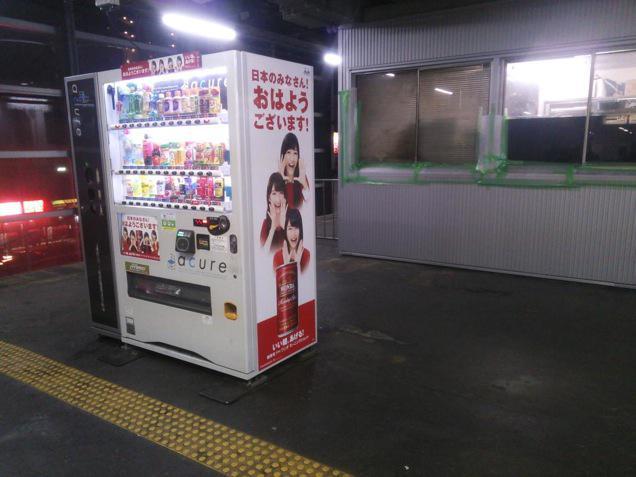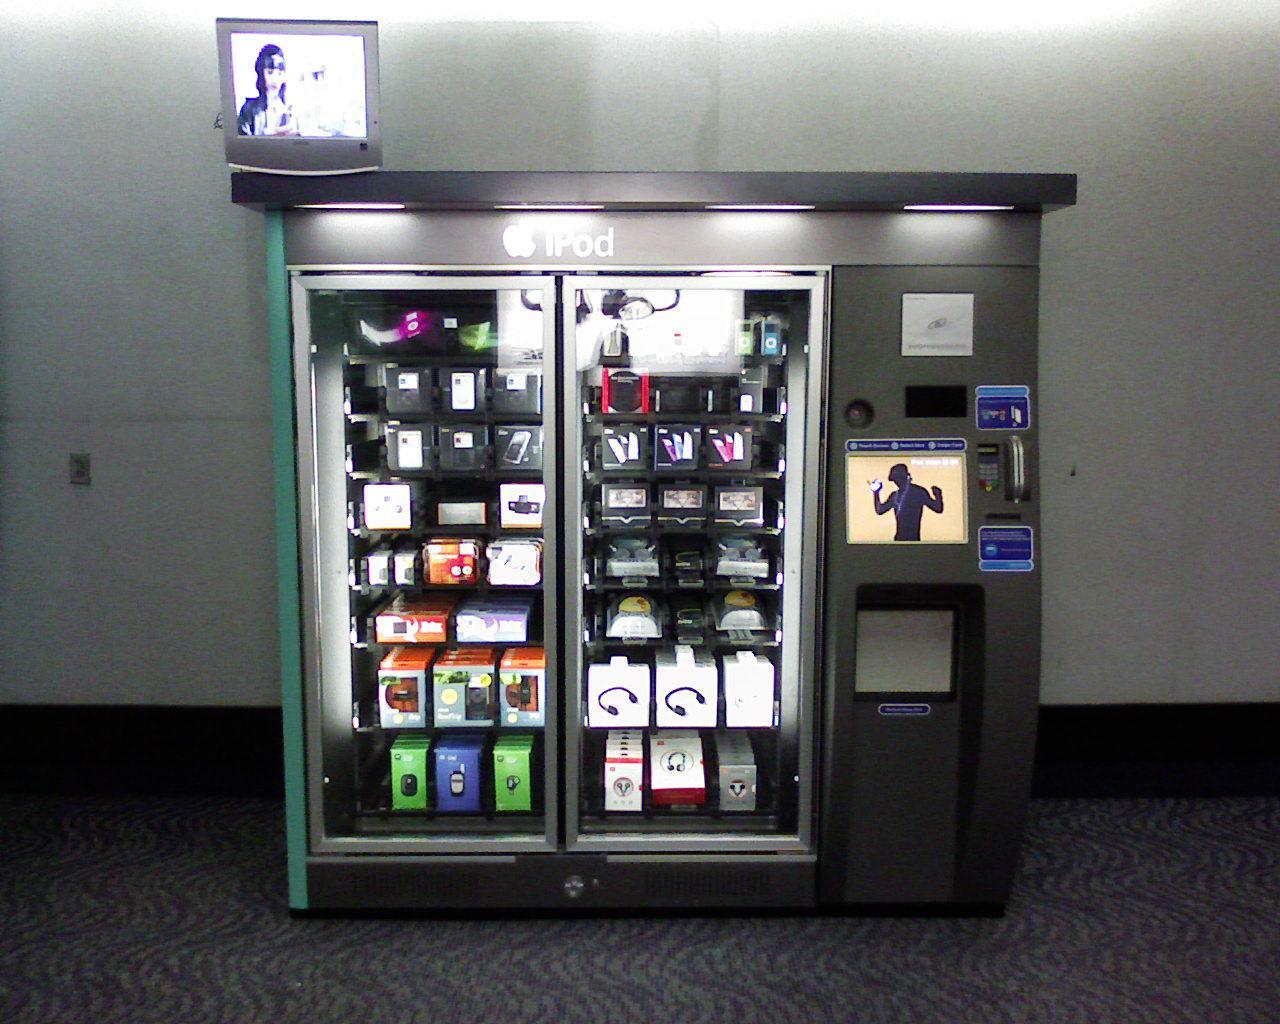The first image is the image on the left, the second image is the image on the right. Given the left and right images, does the statement "One of the images clearly shows a blue vending machine placed directly next to a red vending machine." hold true? Answer yes or no. No. The first image is the image on the left, the second image is the image on the right. Examine the images to the left and right. Is the description "A blue vending machine and a red vending machine are side by side." accurate? Answer yes or no. No. 